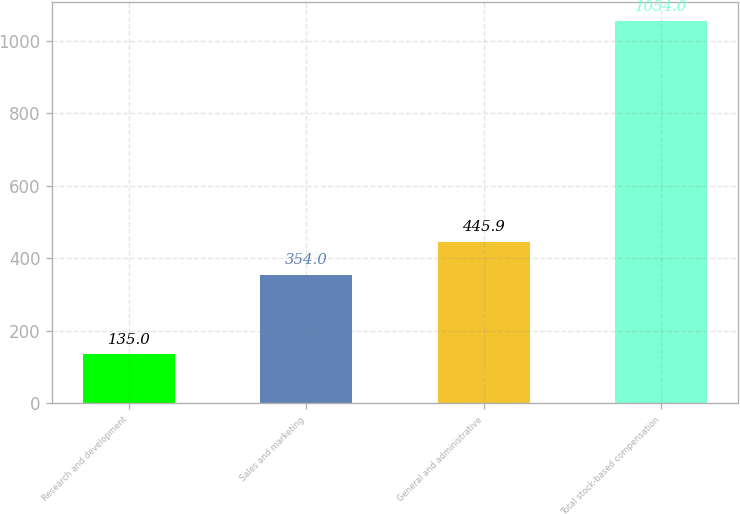Convert chart to OTSL. <chart><loc_0><loc_0><loc_500><loc_500><bar_chart><fcel>Research and development<fcel>Sales and marketing<fcel>General and administrative<fcel>Total stock-based compensation<nl><fcel>135<fcel>354<fcel>445.9<fcel>1054<nl></chart> 